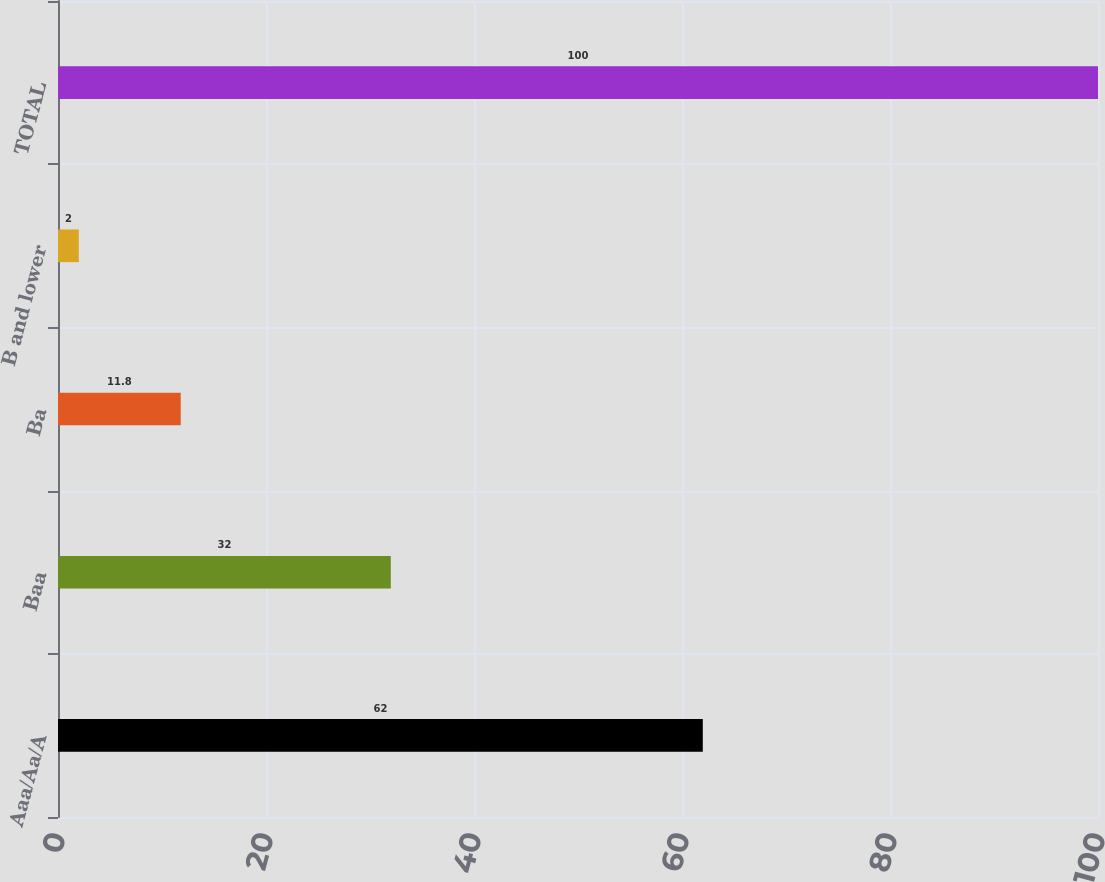Convert chart to OTSL. <chart><loc_0><loc_0><loc_500><loc_500><bar_chart><fcel>Aaa/Aa/A<fcel>Baa<fcel>Ba<fcel>B and lower<fcel>TOTAL<nl><fcel>62<fcel>32<fcel>11.8<fcel>2<fcel>100<nl></chart> 